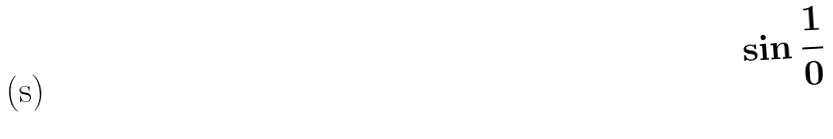<formula> <loc_0><loc_0><loc_500><loc_500>\sin \frac { 1 } { 0 }</formula> 